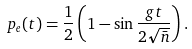<formula> <loc_0><loc_0><loc_500><loc_500>p _ { e } ( t ) = \frac { 1 } { 2 } \left ( 1 - \sin \frac { g t } { 2 \sqrt { \bar { n } } } \right ) .</formula> 